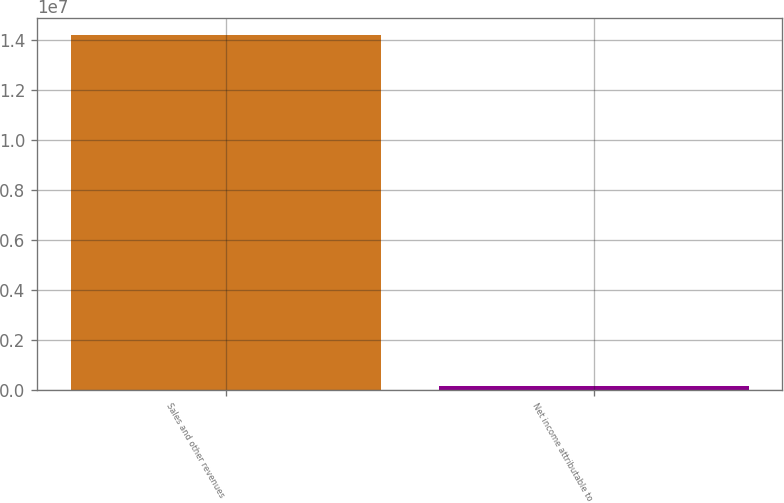Convert chart to OTSL. <chart><loc_0><loc_0><loc_500><loc_500><bar_chart><fcel>Sales and other revenues<fcel>Net income attributable to<nl><fcel>1.42078e+07<fcel>179979<nl></chart> 